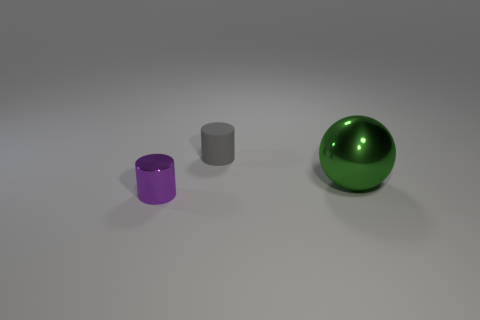There is a cylinder that is in front of the shiny thing that is behind the shiny thing that is in front of the ball; what is its size?
Offer a terse response. Small. Is the number of green metallic spheres that are in front of the large green metallic sphere greater than the number of big green metallic spheres that are behind the gray matte cylinder?
Offer a very short reply. No. How many small shiny cylinders are in front of the metallic object that is behind the purple metallic cylinder?
Your answer should be very brief. 1. Are there any other shiny objects that have the same color as the large metallic thing?
Ensure brevity in your answer.  No. Does the gray cylinder have the same size as the purple shiny cylinder?
Ensure brevity in your answer.  Yes. Is the small matte cylinder the same color as the large sphere?
Make the answer very short. No. The cylinder behind the cylinder in front of the large object is made of what material?
Provide a succinct answer. Rubber. What material is the other tiny thing that is the same shape as the small gray matte thing?
Make the answer very short. Metal. There is a shiny thing left of the rubber thing; is it the same size as the rubber thing?
Offer a terse response. Yes. How many shiny things are tiny blue things or green spheres?
Offer a very short reply. 1. 